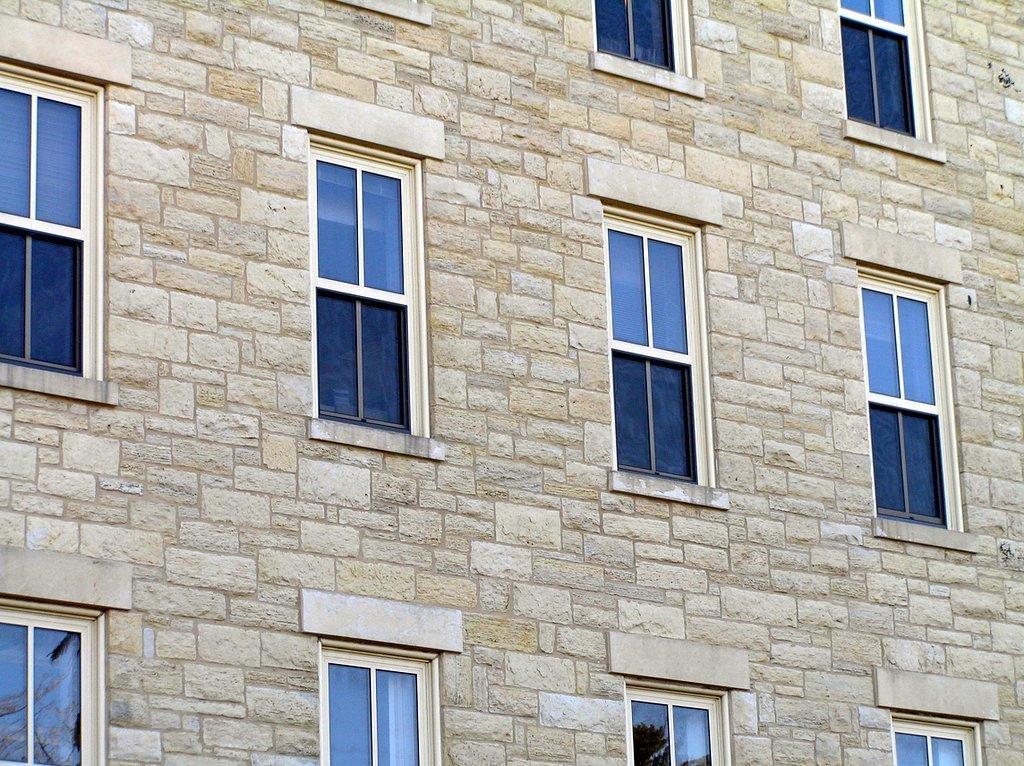Describe this image in one or two sentences. In this image there is a wall to which there are so many windows. There are glass windows to the wall. 